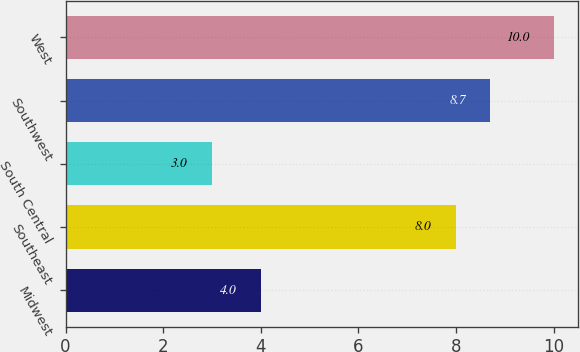<chart> <loc_0><loc_0><loc_500><loc_500><bar_chart><fcel>Midwest<fcel>Southeast<fcel>South Central<fcel>Southwest<fcel>West<nl><fcel>4<fcel>8<fcel>3<fcel>8.7<fcel>10<nl></chart> 